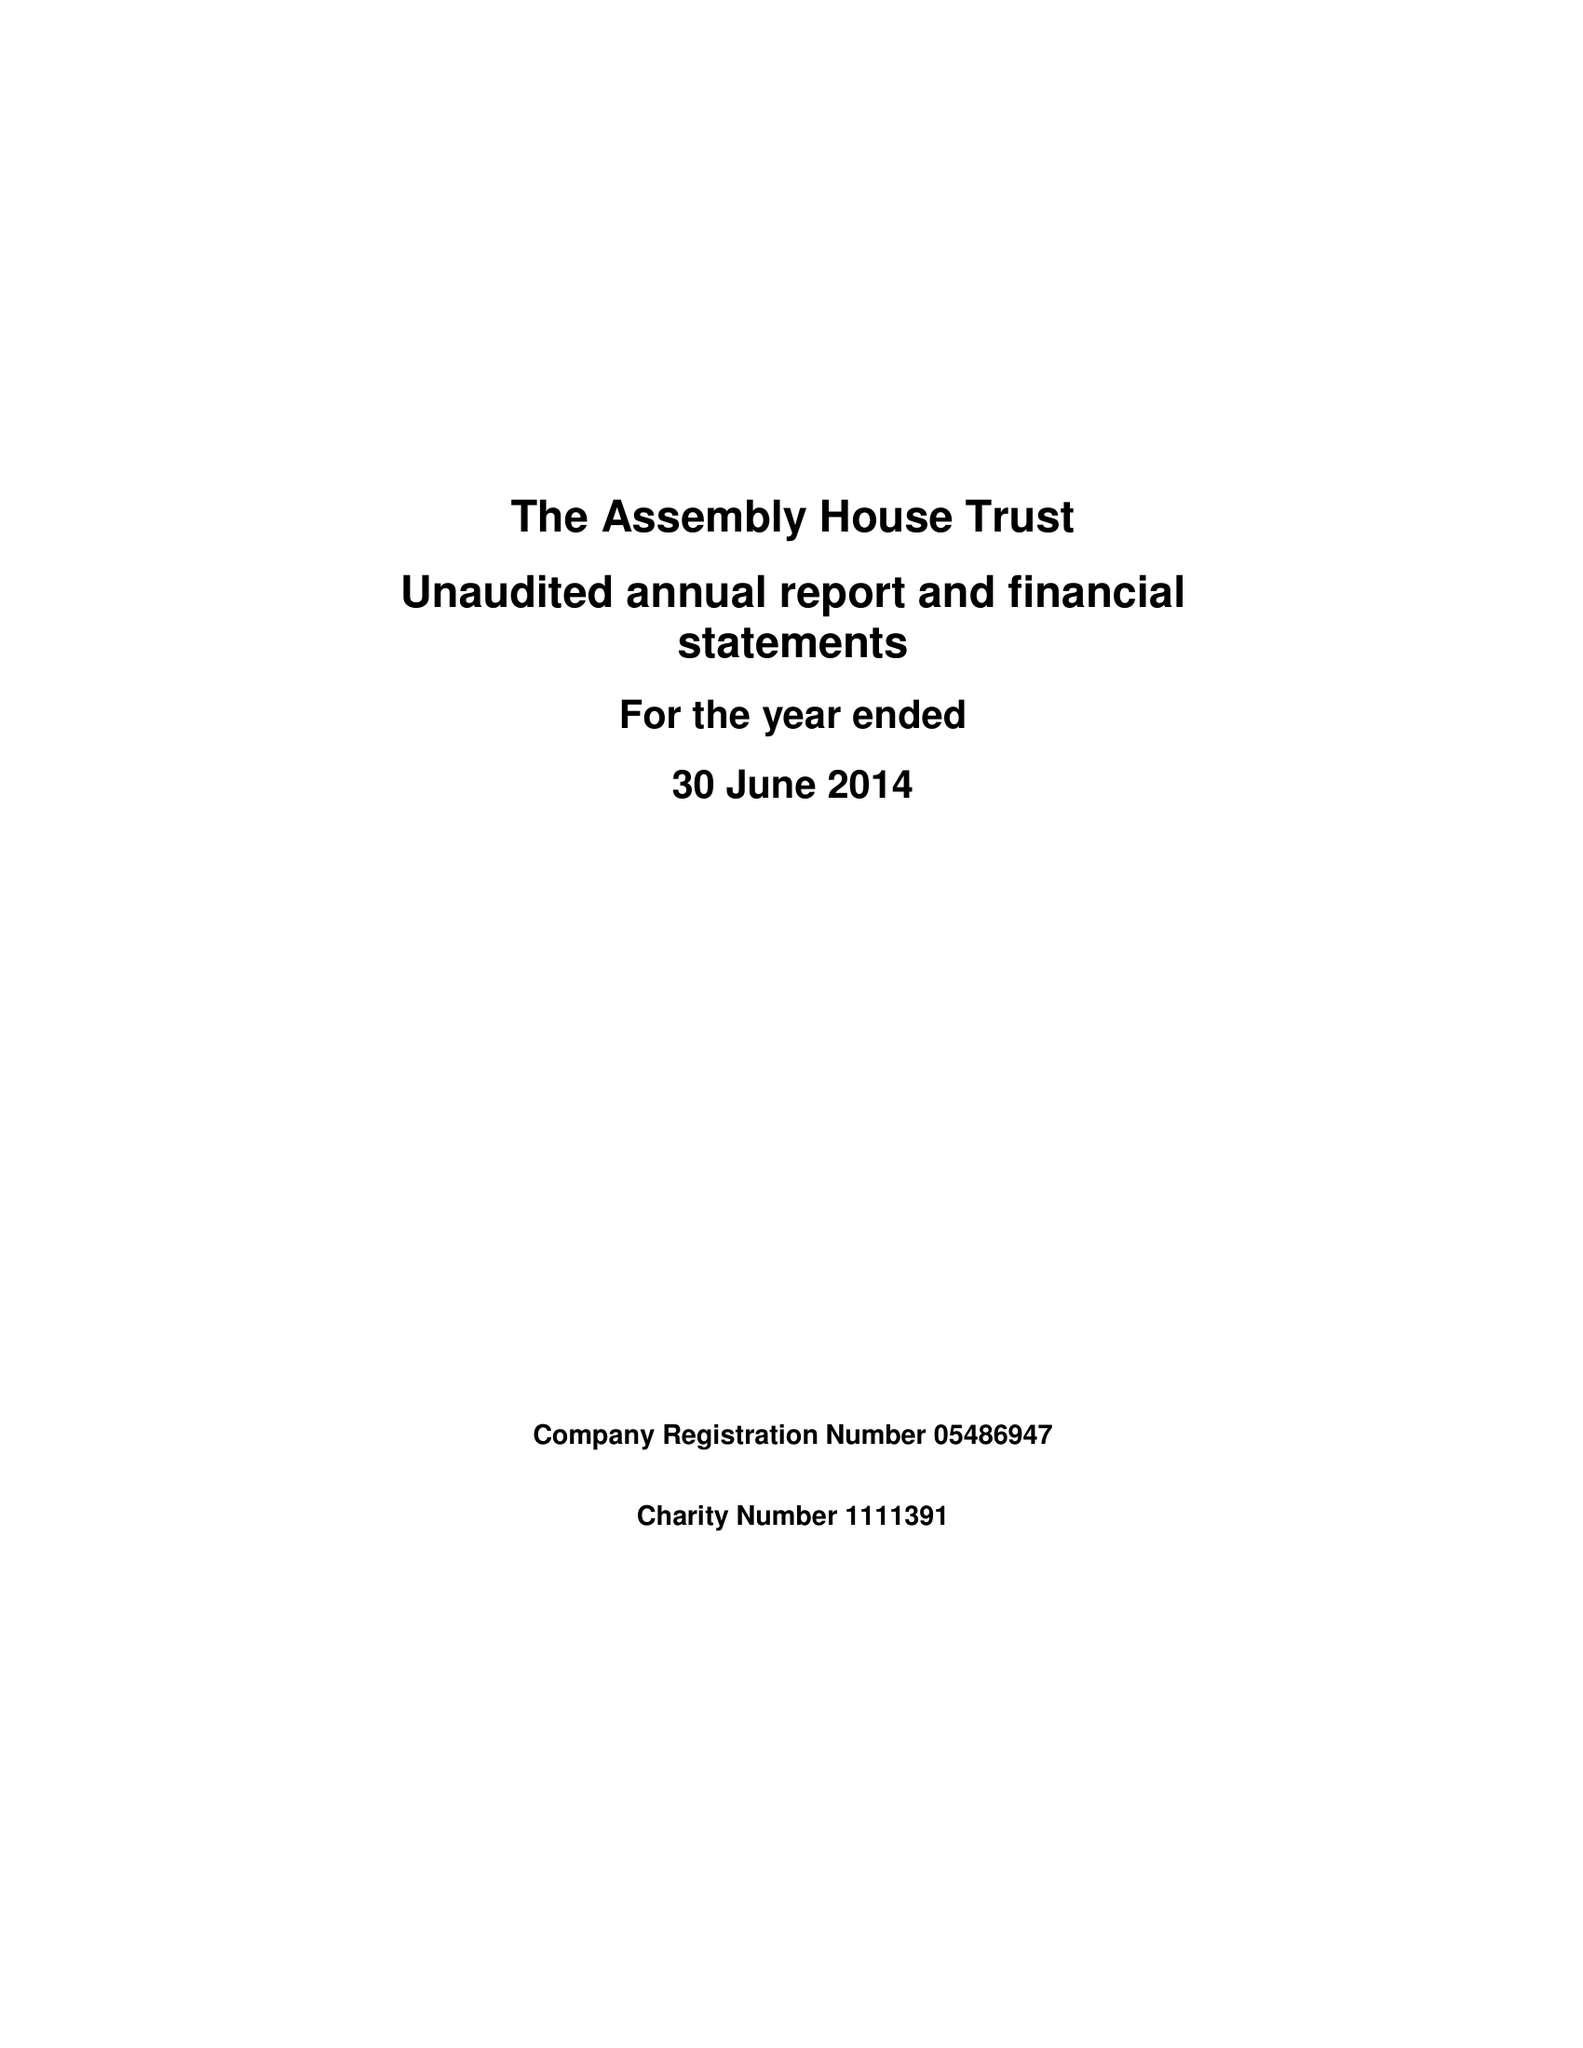What is the value for the income_annually_in_british_pounds?
Answer the question using a single word or phrase. 175020.00 